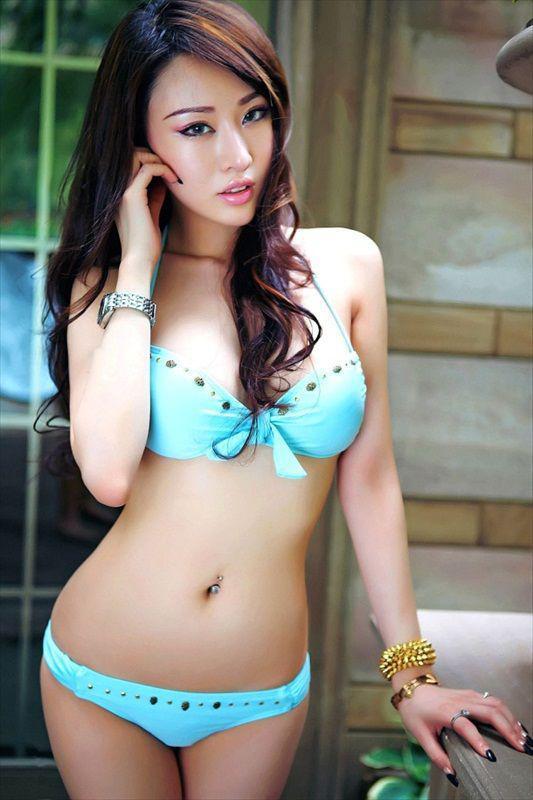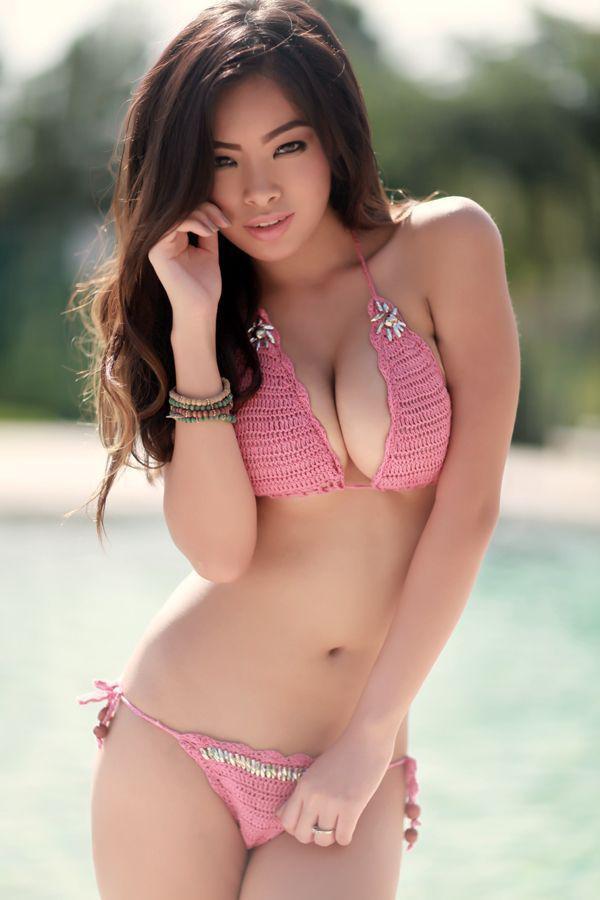The first image is the image on the left, the second image is the image on the right. Evaluate the accuracy of this statement regarding the images: "Three camera-facing swimwear models stand side-by-side in front of a swimming pool.". Is it true? Answer yes or no. No. The first image is the image on the left, the second image is the image on the right. For the images shown, is this caption "There are no more than three women." true? Answer yes or no. Yes. 